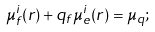Convert formula to latex. <formula><loc_0><loc_0><loc_500><loc_500>\mu _ { f } ^ { i } ( r ) + q _ { f } \mu _ { e } ^ { i } ( r ) = \mu _ { q } ;</formula> 